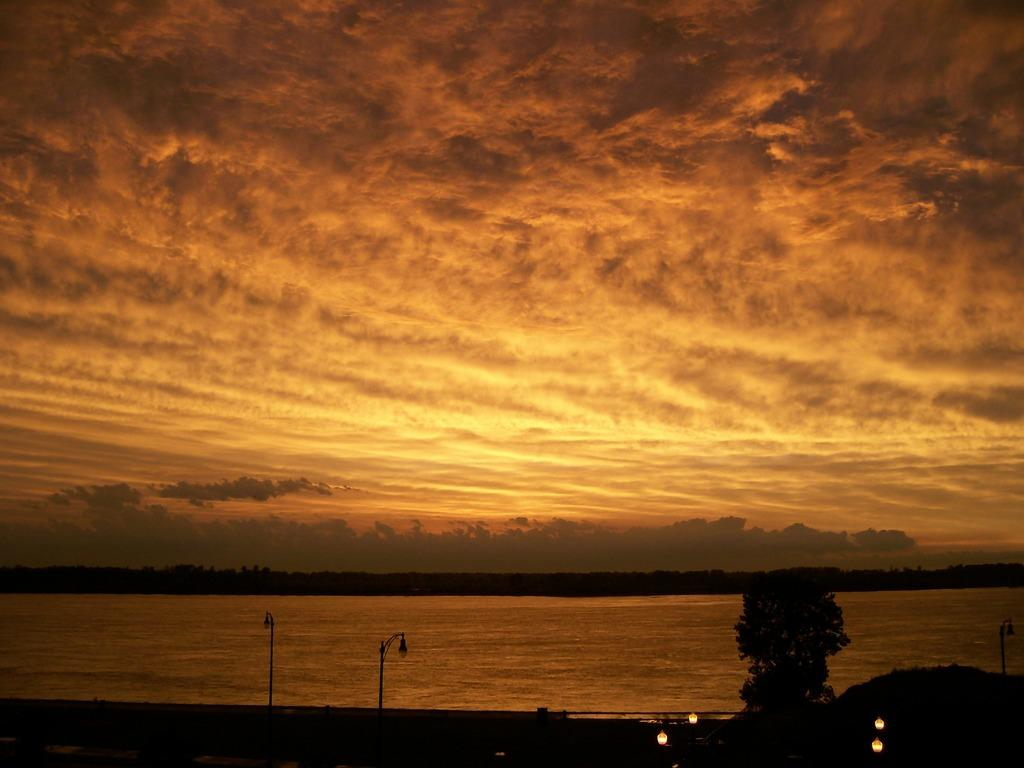What is the main feature of the image? There is a road in the image. What can be seen along the road? Lamps are present along the road. What is visible in the background of the image? There is a river, trees, and the sky visible in the background of the image. Can you tell me how many people are involved in the fight in the image? There is no fight present in the image; it features a road, lamps, a river, trees, and the sky. 